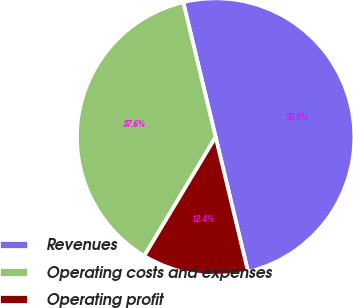Convert chart. <chart><loc_0><loc_0><loc_500><loc_500><pie_chart><fcel>Revenues<fcel>Operating costs and expenses<fcel>Operating profit<nl><fcel>50.0%<fcel>37.64%<fcel>12.36%<nl></chart> 